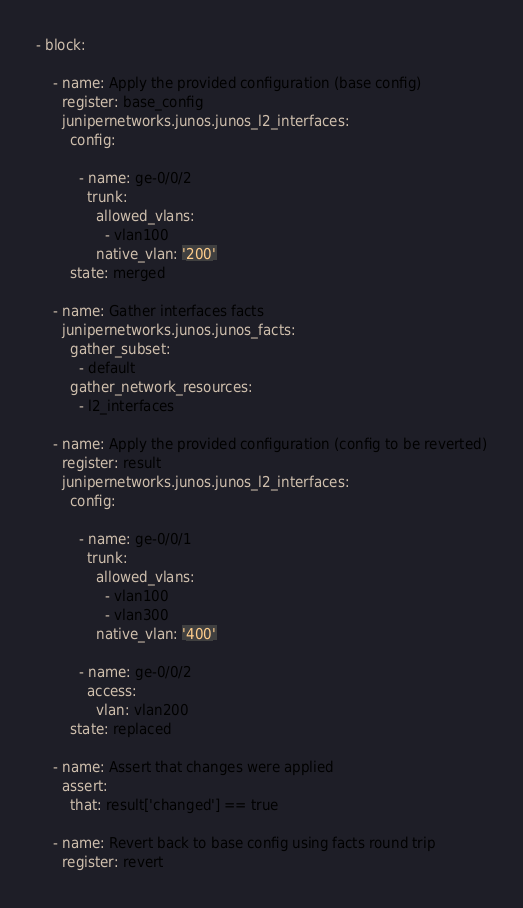<code> <loc_0><loc_0><loc_500><loc_500><_YAML_>- block:

    - name: Apply the provided configuration (base config)
      register: base_config
      junipernetworks.junos.junos_l2_interfaces:
        config:

          - name: ge-0/0/2
            trunk:
              allowed_vlans:
                - vlan100
              native_vlan: '200'
        state: merged

    - name: Gather interfaces facts
      junipernetworks.junos.junos_facts:
        gather_subset:
          - default
        gather_network_resources:
          - l2_interfaces

    - name: Apply the provided configuration (config to be reverted)
      register: result
      junipernetworks.junos.junos_l2_interfaces:
        config:

          - name: ge-0/0/1
            trunk:
              allowed_vlans:
                - vlan100
                - vlan300
              native_vlan: '400'

          - name: ge-0/0/2
            access:
              vlan: vlan200
        state: replaced

    - name: Assert that changes were applied
      assert:
        that: result['changed'] == true

    - name: Revert back to base config using facts round trip
      register: revert</code> 